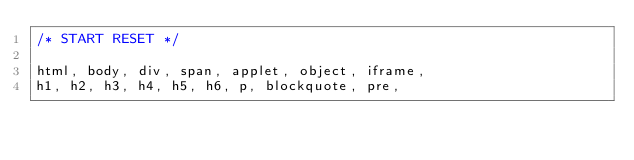<code> <loc_0><loc_0><loc_500><loc_500><_CSS_>/* START RESET */

html, body, div, span, applet, object, iframe,
h1, h2, h3, h4, h5, h6, p, blockquote, pre,</code> 